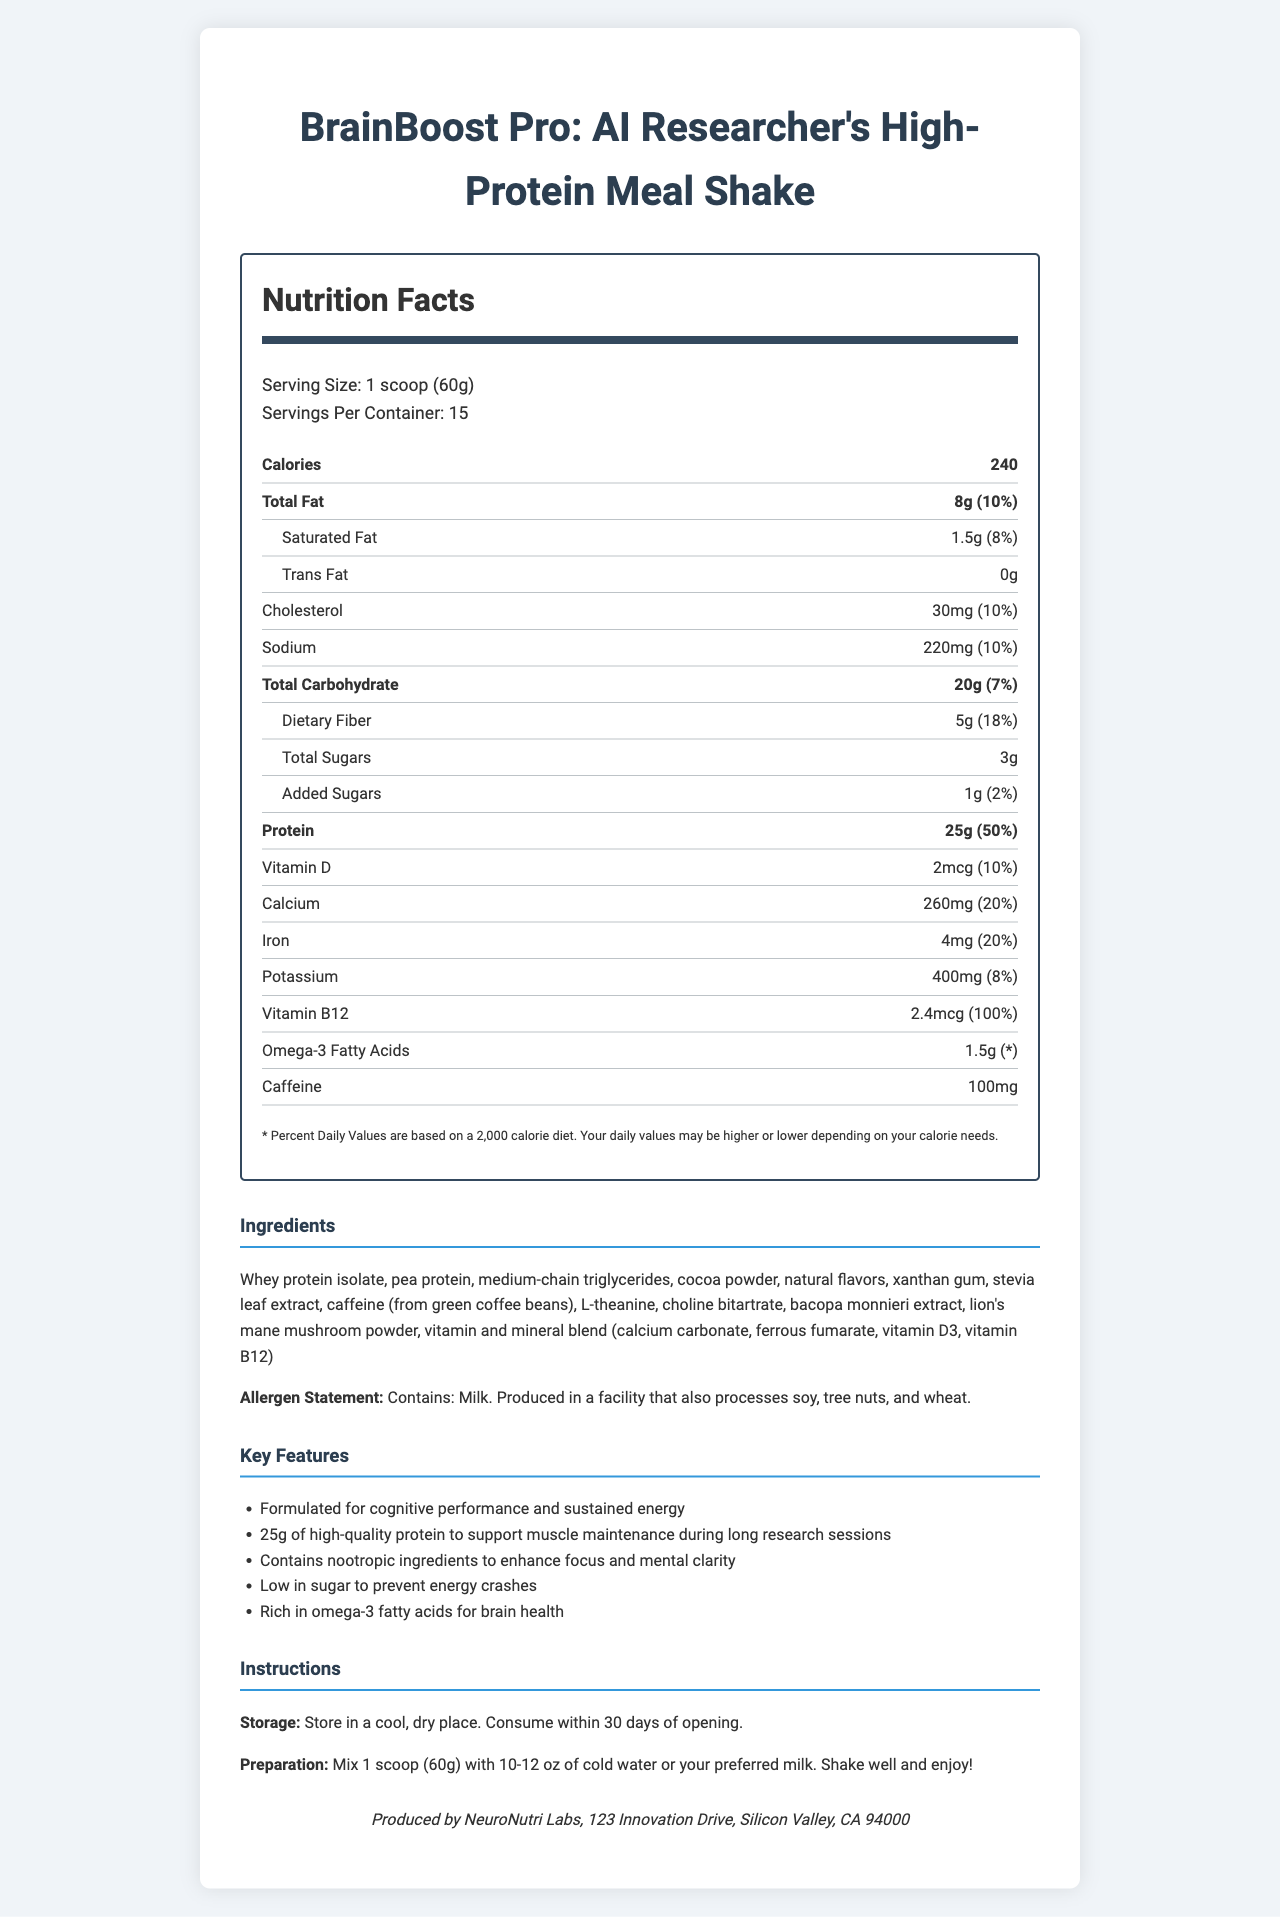what is the serving size? The serving size is specified under "Serving Size: 1 scoop (60g)".
Answer: 1 scoop (60g) how many calories are there per serving? The calorie information is listed under "Calories: 240".
Answer: 240 what is the total fat content in one serving? The total fat per serving is mentioned as 8g with a daily value of 10%.
Answer: 8g (10%) how much cholesterol does one serving contain? The cholesterol content is listed as 30mg, with a daily value of 10%.
Answer: 30mg (10%) what is the amount of sodium per serving? The sodium amount per serving is 220mg with a daily value of 10%.
Answer: 220mg (10%) how many grams of protein are there per serving? The protein content per serving is listed as 25g with a daily value of 50%.
Answer: 25g (50%) what is the amount of dietary fiber in one serving? The dietary fiber content per serving is 5g with a daily value of 18%.
Answer: 5g (18%) which ingredient is not in the meal replacement shake? A. Whey protein isolate B. Sugars C. Pea protein Whey protein isolate and pea protein are listed in the ingredients. Sugars are mentioned, but not as a primary ingredient in the ingredients section.
Answer: B. Sugars what is the preparation instruction for the meal replacement shake? A. Mix with hot water B. Mix with 10-12 oz of cold water or preferred milk C. Blend with fruits The preparation instructions specifically state to mix 1 scoop with 10-12 oz of cold water or your preferred milk.
Answer: B. Mix with 10-12 oz of cold water or preferred milk how many servings are in each container? The number of servings per container is specified as 15.
Answer: 15 does the product contain Omega-3 fatty acids? Omega-3 fatty acids are listed in the nutrition facts with an amount of 1.5g.
Answer: Yes is this product gluten-free? The allergen statement mentions milk and processing in a facility that also processes soy, tree nuts, and wheat, but does not specify if the product is gluten-free.
Answer: Not enough information what is the main purpose of the BrainBoost Pro shake? One of the claim statements explicitly mentions: "Formulated for cognitive performance and sustained energy".
Answer: Formulated for cognitive performance and sustained energy what is the allergen statement for this product? The allergen statement is given in the ingredients section.
Answer: Contains: Milk. Produced in a facility that also processes soy, tree nuts, and wheat. describe the entire document or the main idea? The document is a detailed nutrition facts label for the BrainBoost Pro meal replacement shake, highlighting its nutritional content, key features, and instructions for use.
Answer: The BrainBoost Pro: AI Researcher's High-Protein Meal Shake is designed for busy researchers. It provides detailed nutritional information, including a high protein content of 25g per serving, low sugars, various vitamins and minerals, and other beneficial ingredients like omega-3 fatty acids and nootropic compounds. The label also includes storage and preparation instructions, key feature claims, ingredient list, and allergen warnings. 